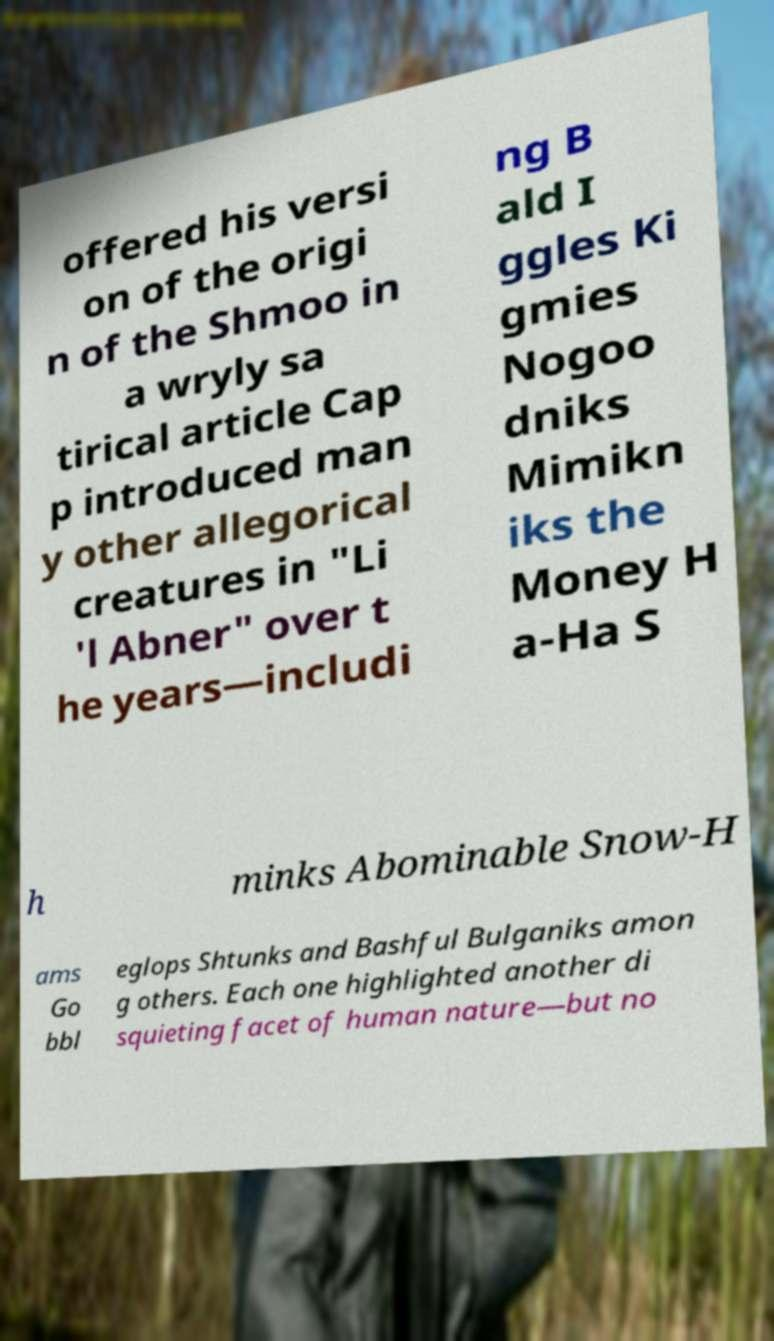For documentation purposes, I need the text within this image transcribed. Could you provide that? offered his versi on of the origi n of the Shmoo in a wryly sa tirical article Cap p introduced man y other allegorical creatures in "Li 'l Abner" over t he years—includi ng B ald I ggles Ki gmies Nogoo dniks Mimikn iks the Money H a-Ha S h minks Abominable Snow-H ams Go bbl eglops Shtunks and Bashful Bulganiks amon g others. Each one highlighted another di squieting facet of human nature—but no 